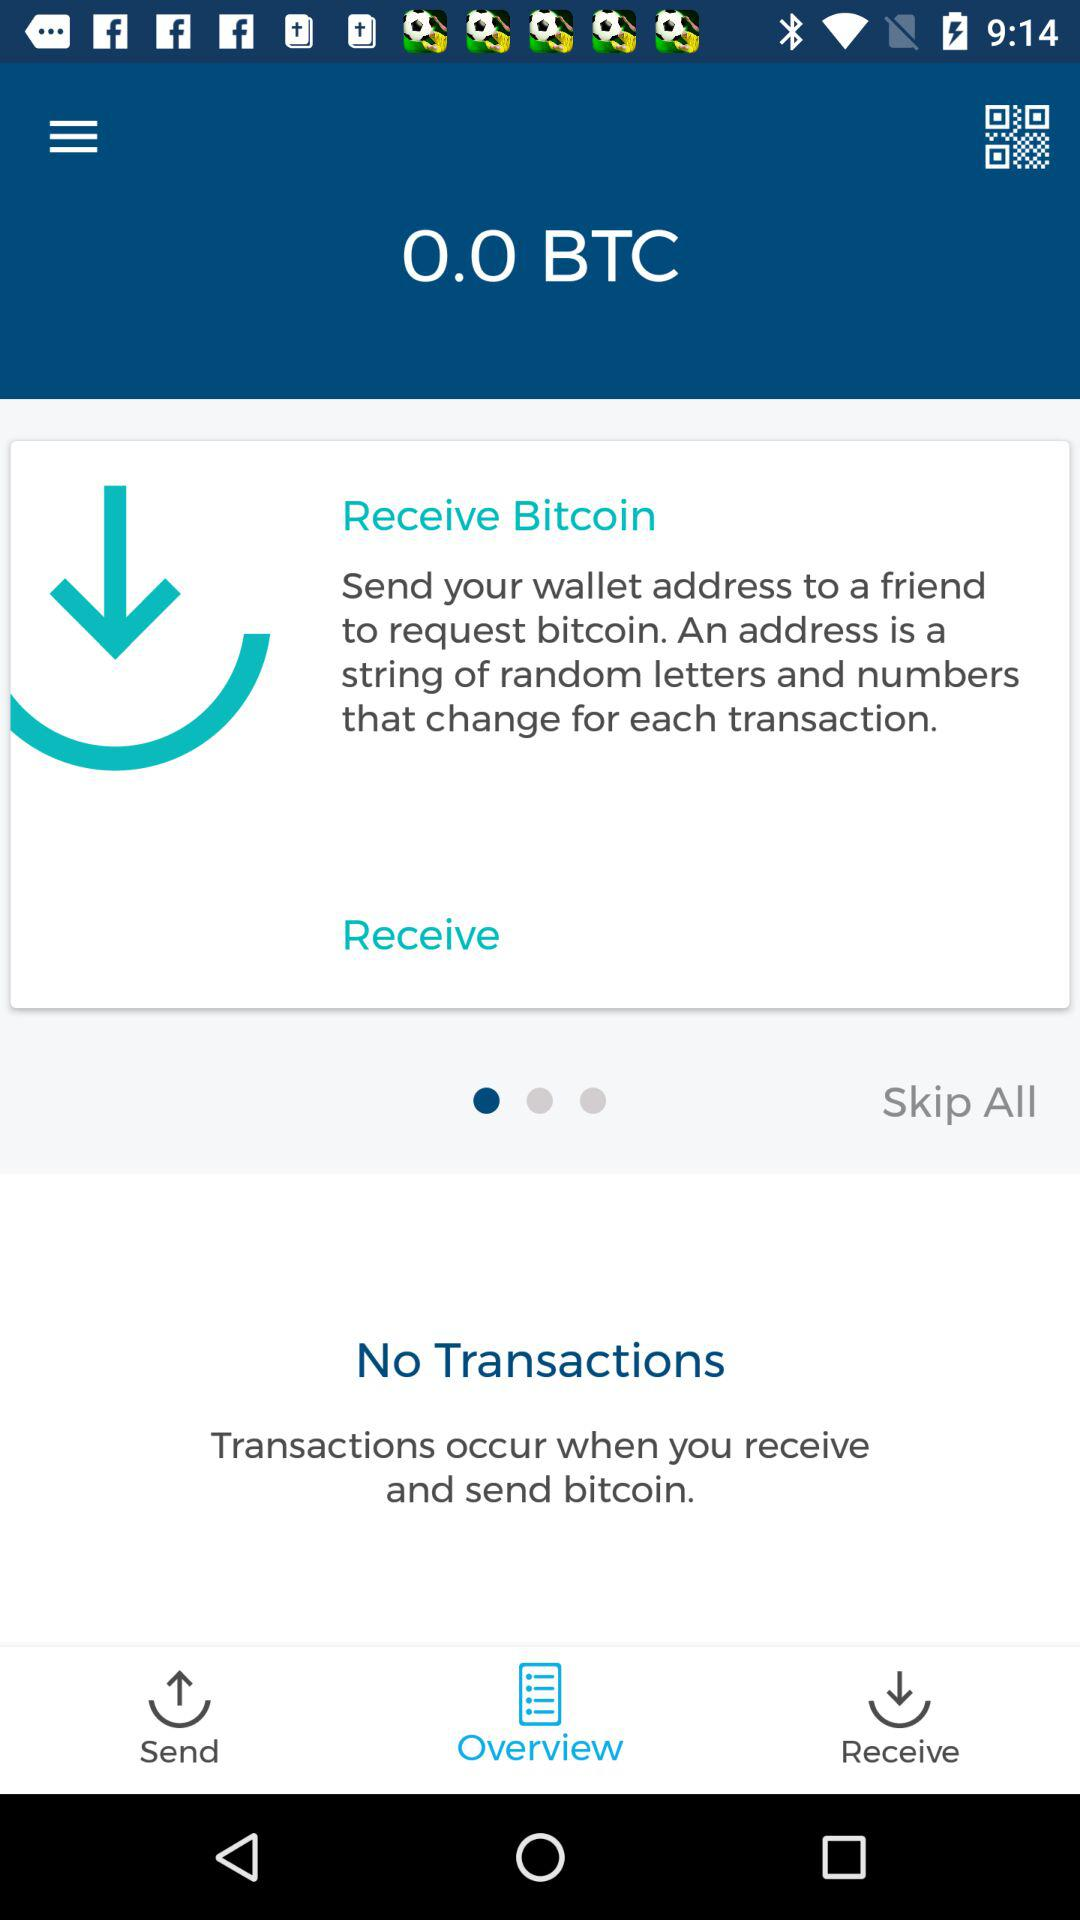How much bitcoin do I have?
Answer the question using a single word or phrase. 0.0 BTC 